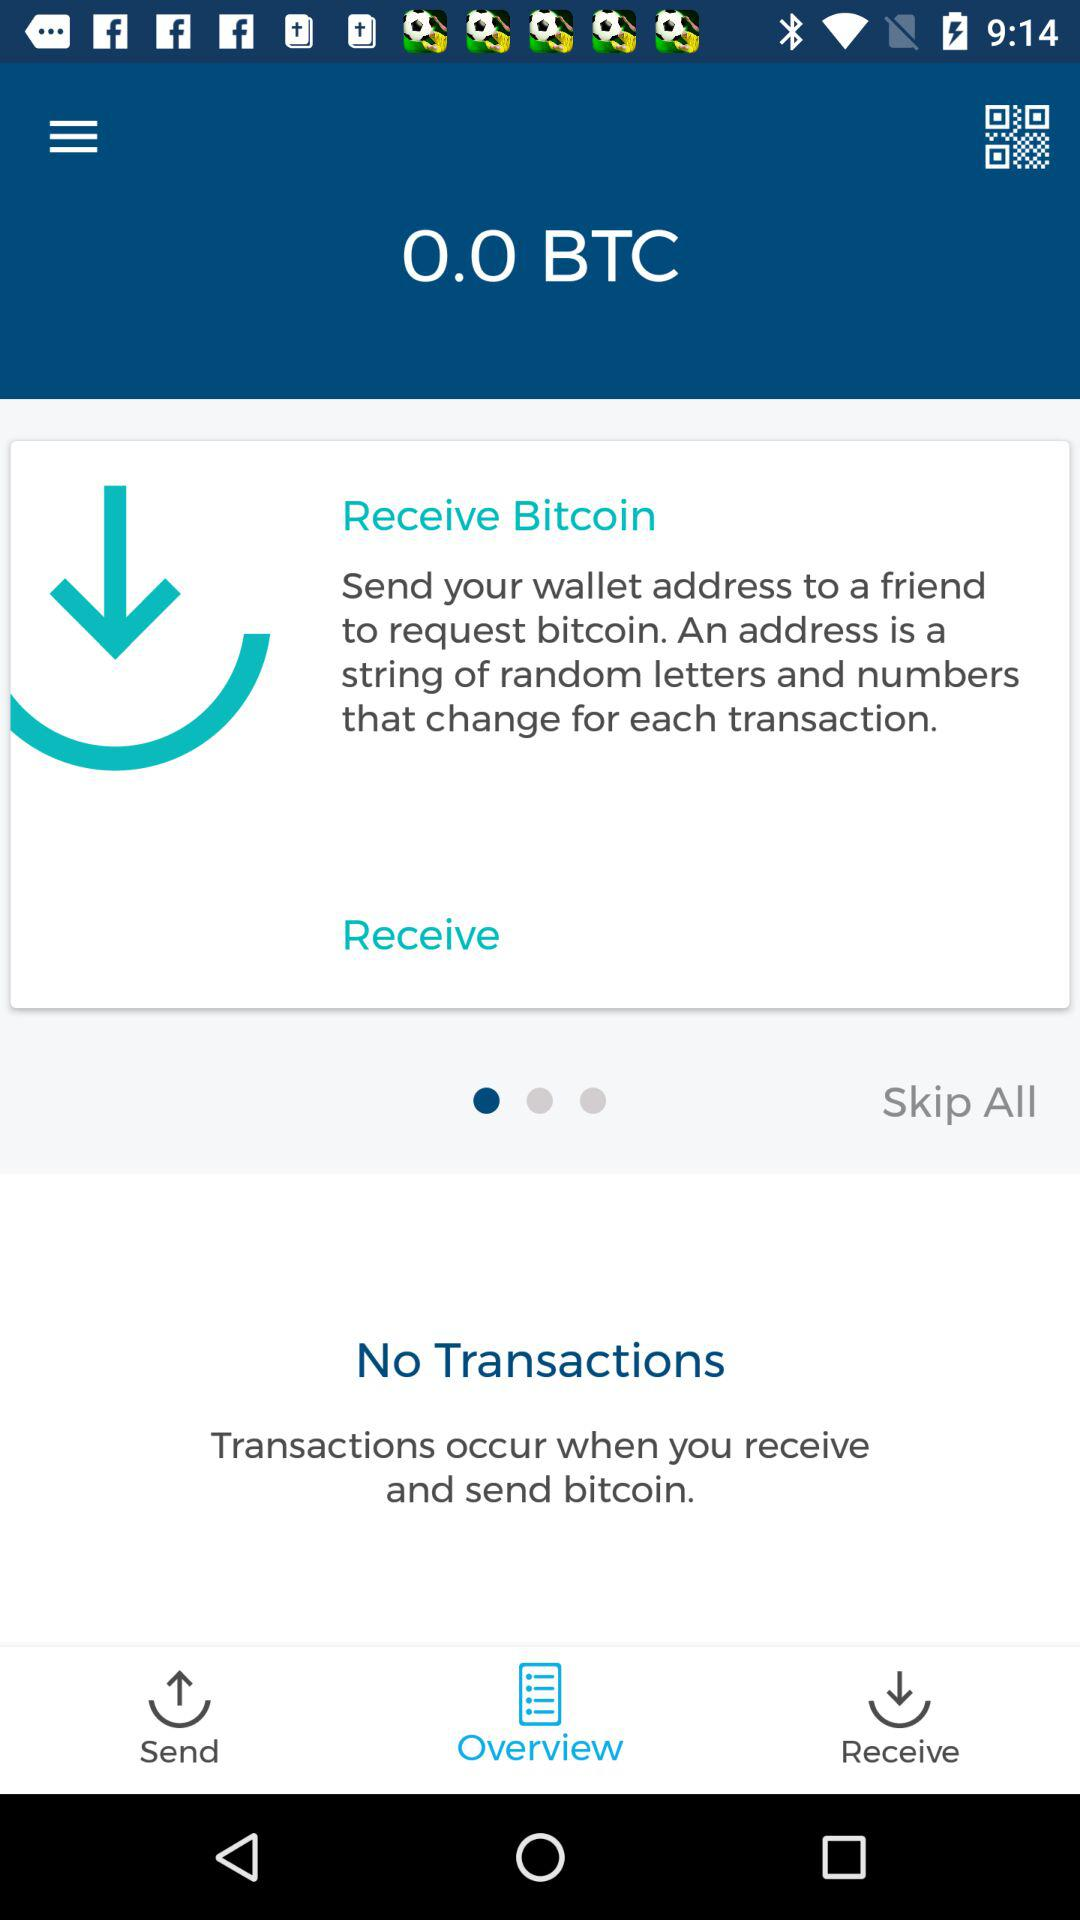How much bitcoin do I have?
Answer the question using a single word or phrase. 0.0 BTC 